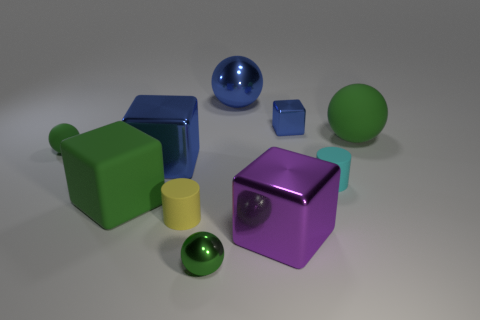What is the shape of the big object that is the same color as the large matte cube?
Provide a succinct answer. Sphere. Is the number of large metal things that are left of the yellow matte thing less than the number of small balls?
Ensure brevity in your answer.  Yes. What shape is the tiny metallic thing in front of the rubber ball right of the small shiny sphere?
Offer a terse response. Sphere. The big rubber block has what color?
Your response must be concise. Green. How many other objects are there of the same size as the rubber cube?
Keep it short and to the point. 4. There is a ball that is in front of the big metallic sphere and on the right side of the small metal ball; what is it made of?
Your answer should be compact. Rubber. Is the size of the blue metallic cube on the right side of the yellow object the same as the cyan rubber object?
Your answer should be very brief. Yes. Do the small metal cube and the big rubber cube have the same color?
Make the answer very short. No. What number of balls are both behind the small matte sphere and in front of the purple object?
Give a very brief answer. 0. How many small rubber balls are on the right side of the small shiny thing on the right side of the small green ball in front of the green cube?
Make the answer very short. 0. 